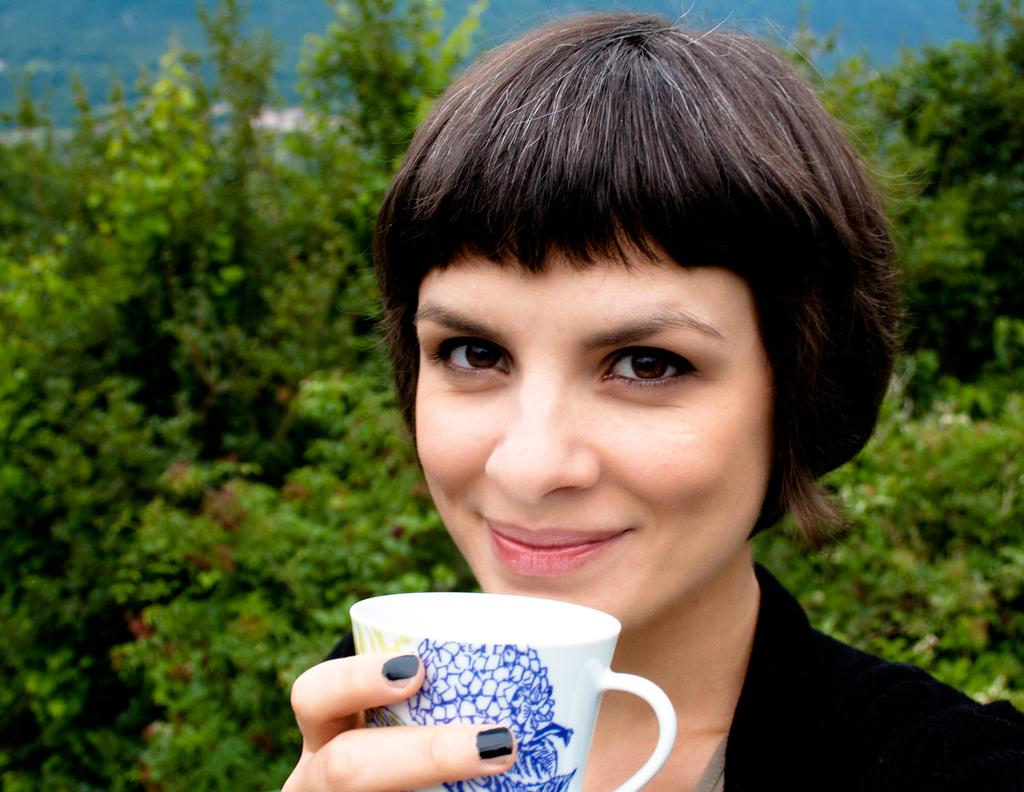Who is the main subject in the image? There is a woman in the image. What is the woman wearing? The woman is wearing a black dress. What is the woman holding in her hands? The woman is holding a cup in her hands. What is the woman's facial expression? The woman is smiling. What can be seen in the background of the image? There are trees in the background of the image. What is the color of the trees? The trees are green in color. What type of pancake is the woman eating in the image? There is no pancake present in the image; the woman is holding a cup. What type of sweater is the woman wearing in the image? The woman is not wearing a sweater in the image; she is wearing a black dress. 